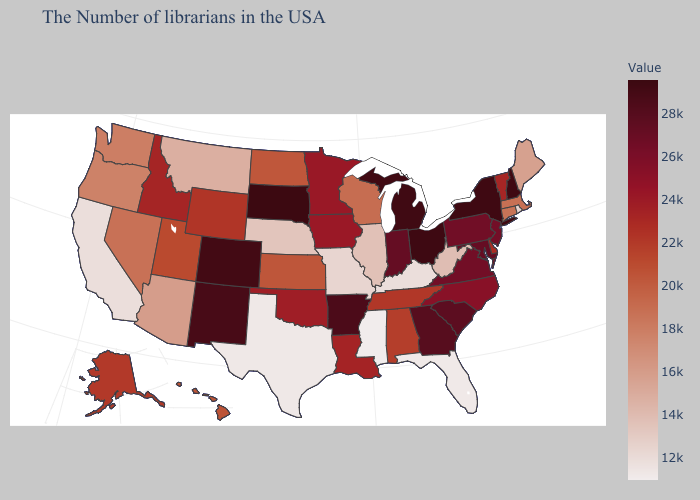Does the map have missing data?
Quick response, please. No. Which states hav the highest value in the West?
Quick response, please. Colorado. Which states have the lowest value in the USA?
Be succinct. Mississippi. Which states have the lowest value in the South?
Keep it brief. Mississippi. Which states hav the highest value in the MidWest?
Concise answer only. South Dakota. Does South Dakota have the highest value in the USA?
Write a very short answer. Yes. 